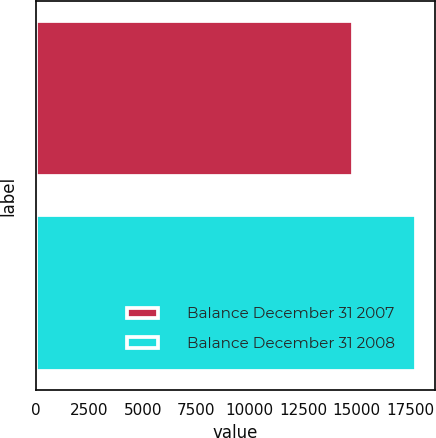Convert chart. <chart><loc_0><loc_0><loc_500><loc_500><bar_chart><fcel>Balance December 31 2007<fcel>Balance December 31 2008<nl><fcel>14842<fcel>17758<nl></chart> 